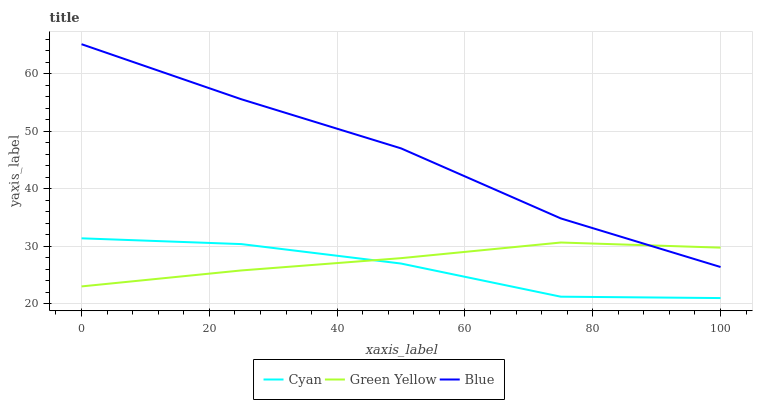Does Green Yellow have the minimum area under the curve?
Answer yes or no. No. Does Green Yellow have the maximum area under the curve?
Answer yes or no. No. Is Cyan the smoothest?
Answer yes or no. No. Is Green Yellow the roughest?
Answer yes or no. No. Does Green Yellow have the lowest value?
Answer yes or no. No. Does Cyan have the highest value?
Answer yes or no. No. Is Cyan less than Blue?
Answer yes or no. Yes. Is Blue greater than Cyan?
Answer yes or no. Yes. Does Cyan intersect Blue?
Answer yes or no. No. 